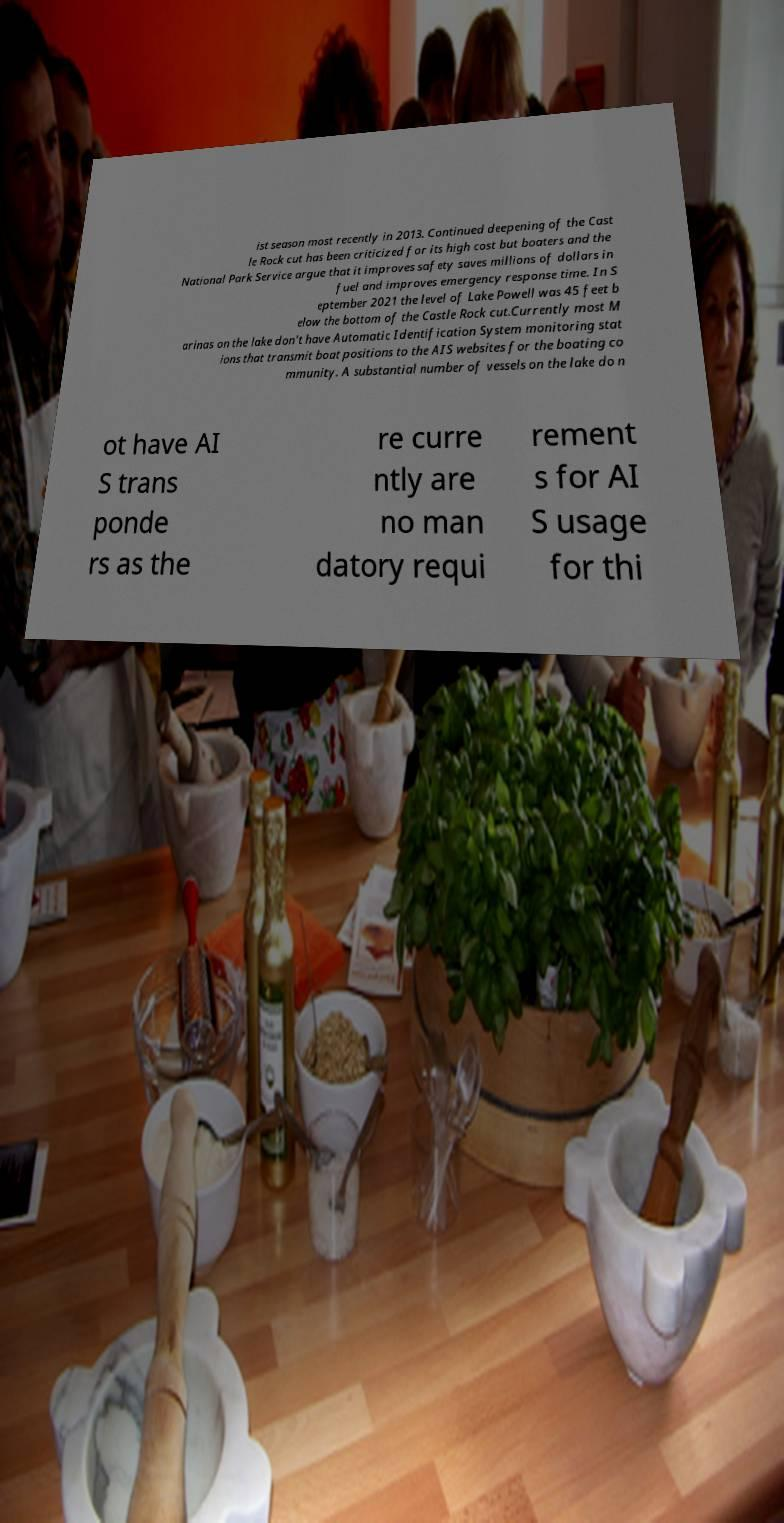Can you accurately transcribe the text from the provided image for me? ist season most recently in 2013. Continued deepening of the Cast le Rock cut has been criticized for its high cost but boaters and the National Park Service argue that it improves safety saves millions of dollars in fuel and improves emergency response time. In S eptember 2021 the level of Lake Powell was 45 feet b elow the bottom of the Castle Rock cut.Currently most M arinas on the lake don't have Automatic Identification System monitoring stat ions that transmit boat positions to the AIS websites for the boating co mmunity. A substantial number of vessels on the lake do n ot have AI S trans ponde rs as the re curre ntly are no man datory requi rement s for AI S usage for thi 